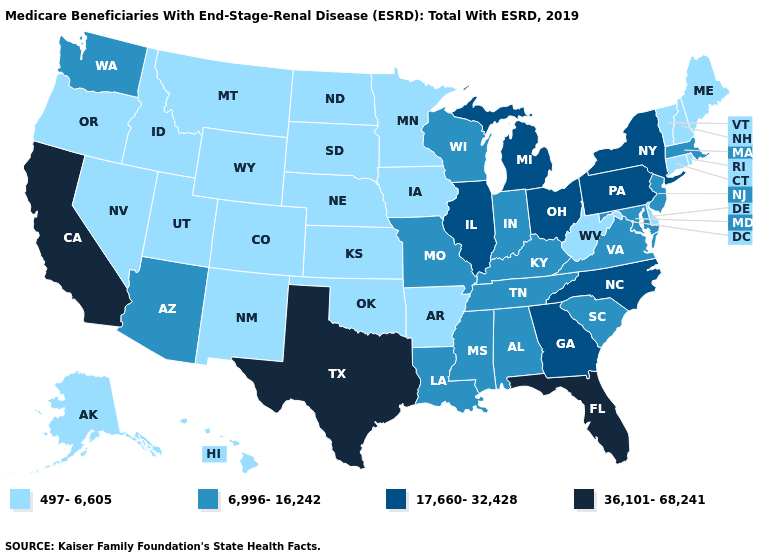Does Connecticut have the highest value in the USA?
Be succinct. No. Name the states that have a value in the range 497-6,605?
Answer briefly. Alaska, Arkansas, Colorado, Connecticut, Delaware, Hawaii, Idaho, Iowa, Kansas, Maine, Minnesota, Montana, Nebraska, Nevada, New Hampshire, New Mexico, North Dakota, Oklahoma, Oregon, Rhode Island, South Dakota, Utah, Vermont, West Virginia, Wyoming. Name the states that have a value in the range 6,996-16,242?
Keep it brief. Alabama, Arizona, Indiana, Kentucky, Louisiana, Maryland, Massachusetts, Mississippi, Missouri, New Jersey, South Carolina, Tennessee, Virginia, Washington, Wisconsin. Does Rhode Island have the lowest value in the Northeast?
Short answer required. Yes. What is the lowest value in the South?
Concise answer only. 497-6,605. Does South Dakota have a lower value than Nevada?
Quick response, please. No. Name the states that have a value in the range 497-6,605?
Write a very short answer. Alaska, Arkansas, Colorado, Connecticut, Delaware, Hawaii, Idaho, Iowa, Kansas, Maine, Minnesota, Montana, Nebraska, Nevada, New Hampshire, New Mexico, North Dakota, Oklahoma, Oregon, Rhode Island, South Dakota, Utah, Vermont, West Virginia, Wyoming. Is the legend a continuous bar?
Give a very brief answer. No. Among the states that border Texas , does Louisiana have the lowest value?
Write a very short answer. No. What is the value of Vermont?
Quick response, please. 497-6,605. Name the states that have a value in the range 17,660-32,428?
Keep it brief. Georgia, Illinois, Michigan, New York, North Carolina, Ohio, Pennsylvania. What is the lowest value in the Northeast?
Short answer required. 497-6,605. Name the states that have a value in the range 36,101-68,241?
Answer briefly. California, Florida, Texas. 